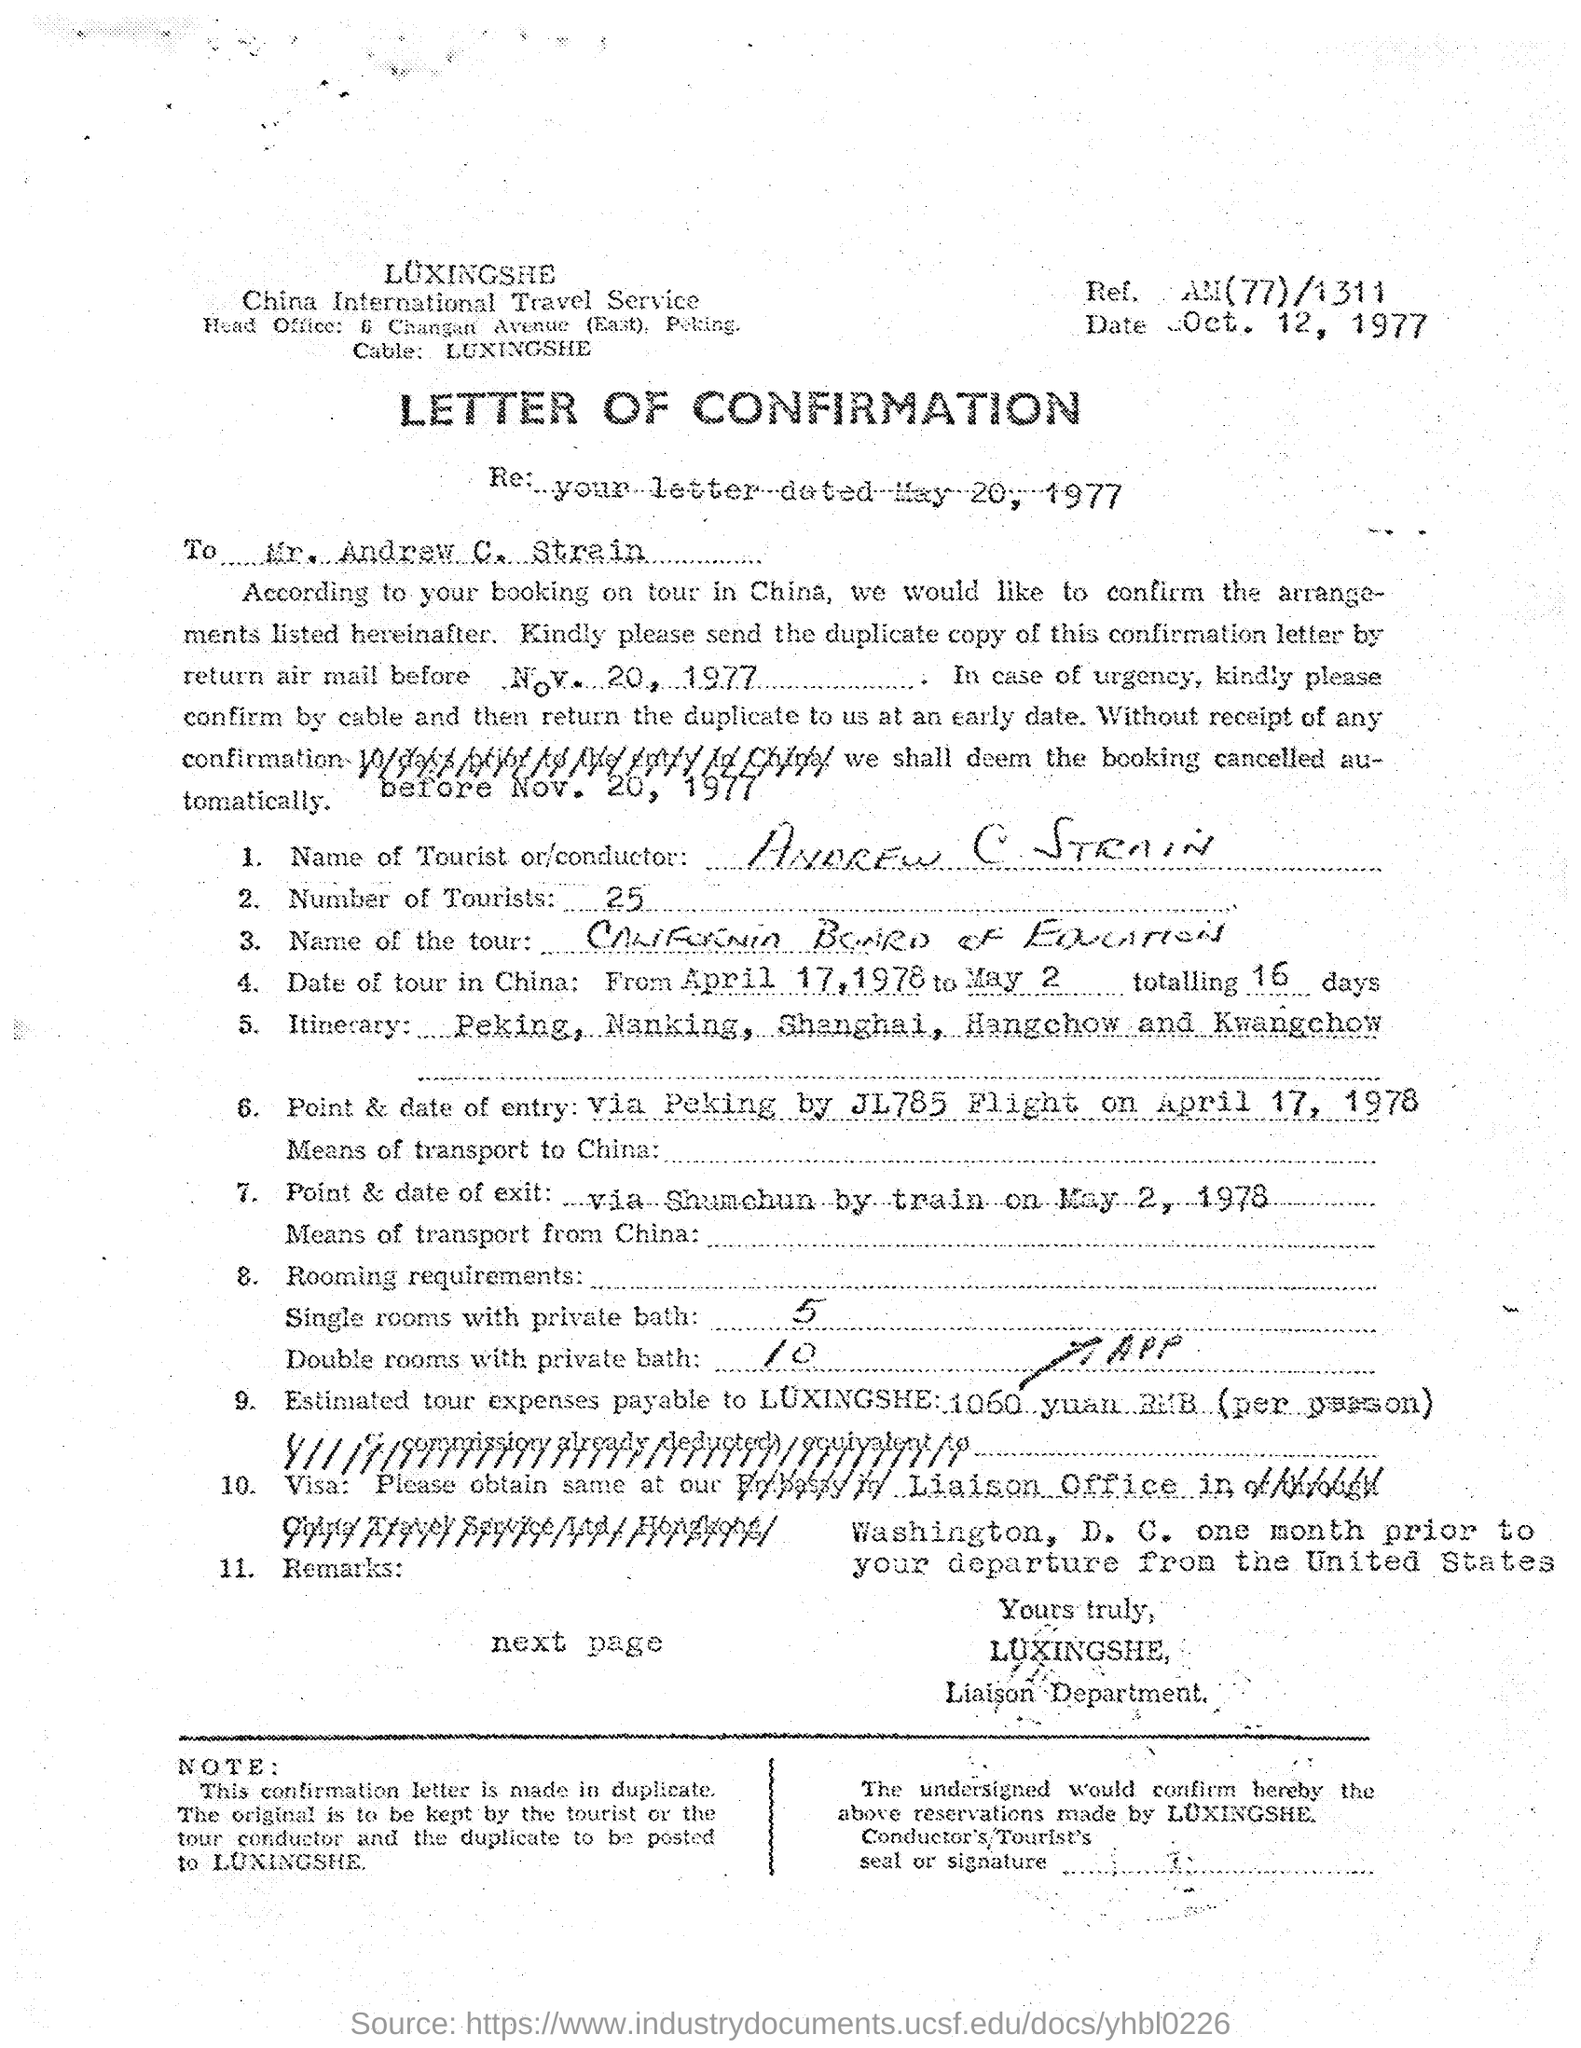What kind of document is given here?
Your answer should be very brief. LETTER OF CONFIRMATION. Who is the addressee of this letter?
Offer a very short reply. MR. ANDREW C. STRAIN. What is the name of Tourist mentioned in the letter?
Provide a short and direct response. ANDREW C STRAIN. How many tourists are there according to the document?
Ensure brevity in your answer.  25. What is the date mentioned in the letterhead?
Provide a short and direct response. Oct. 12, 1977. 